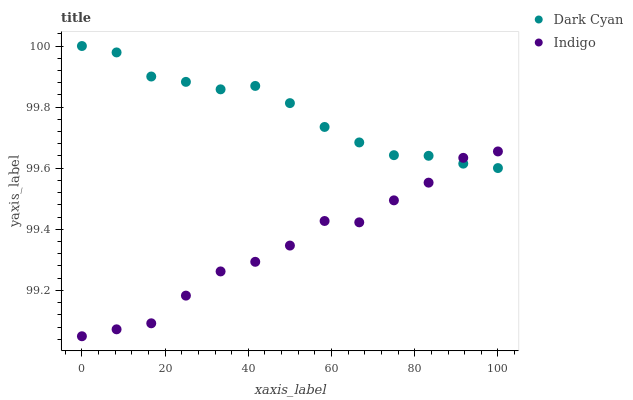Does Indigo have the minimum area under the curve?
Answer yes or no. Yes. Does Dark Cyan have the maximum area under the curve?
Answer yes or no. Yes. Does Indigo have the maximum area under the curve?
Answer yes or no. No. Is Dark Cyan the smoothest?
Answer yes or no. Yes. Is Indigo the roughest?
Answer yes or no. Yes. Is Indigo the smoothest?
Answer yes or no. No. Does Indigo have the lowest value?
Answer yes or no. Yes. Does Dark Cyan have the highest value?
Answer yes or no. Yes. Does Indigo have the highest value?
Answer yes or no. No. Does Indigo intersect Dark Cyan?
Answer yes or no. Yes. Is Indigo less than Dark Cyan?
Answer yes or no. No. Is Indigo greater than Dark Cyan?
Answer yes or no. No. 